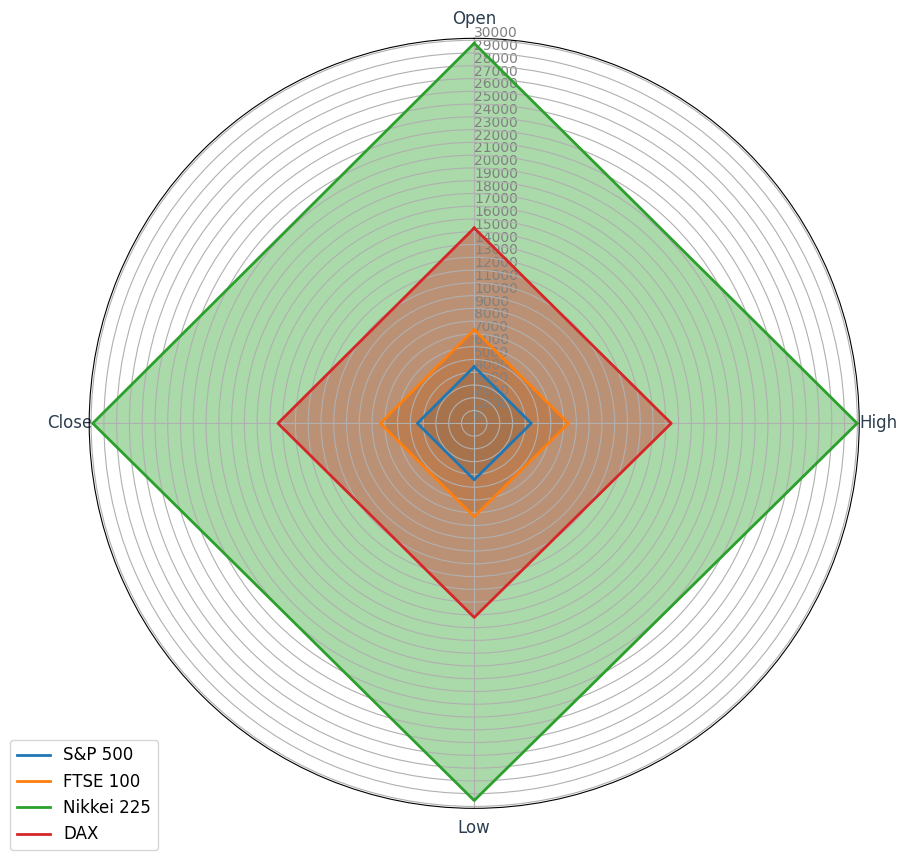Which index shows the highest average 'Close' value? The radar chart shows the 'Close' values for various indices. Observe each index's 'Close' value and identify the highest one.
Answer: Nikkei 225 How does the average 'High' value for S&P 500 compare to that of DAX? Examine the radar chart and compare the 'High' value radials for S&P 500 and DAX. Look at the lengths and identify which is higher.
Answer: S&P 500 is higher Which index has the smallest range between 'High' and 'Low' values? Calculate the difference between 'High' and 'Low' values for each index: S&P 500, FTSE 100, Nikkei 225, and DAX. Identify the smallest range.
Answer: FTSE 100 What is the average 'Open' value for Nikkei 225? Sum the 'Open' values for Nikkei 225 from the chart and divide by the number of data points available.
Answer: 29711.4 Which index has the most consistent 'Low' values, showing the least variation? Evaluate the radials representing 'Low' values for each index. Identify the index where the 'Low' values are nearly the same length.
Answer: DAX How does the variation in 'Close' values for FTSE 100 compare to that for S&P 500? Look at the spread of the 'Close' value radials for FTSE 100 and S&P 500. Determine which has a wider and more inconsistent radial length.
Answer: S&P 500 shows more variation What's the overall trend for 'Open' values across all indices? Observe the radar chart. Analyze whether the 'Open' values for the indices are generally close to the same length or vary significantly.
Answer: Similar trends across all indices Compare the 'Low' values of FTSE 100 and Nikkei 225 to determine which is higher on average. Inspect the radar chart and look at the 'Low' radial representations for FTSE 100 and Nikkei 225. Identify the higher average 'Low' value.
Answer: Nikkei 225 